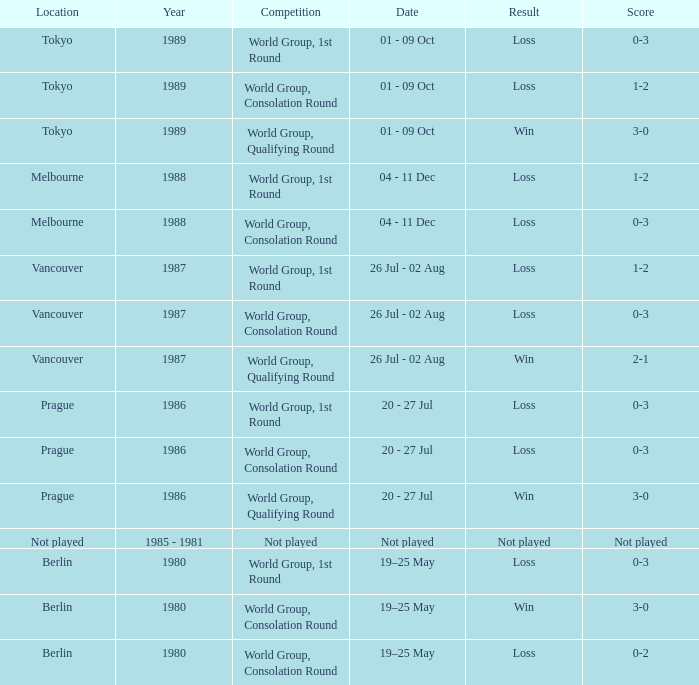What is the date for the game in prague for the world group, consolation round competition? 20 - 27 Jul. 